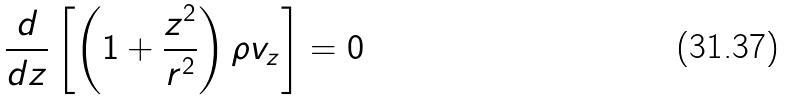<formula> <loc_0><loc_0><loc_500><loc_500>\frac { d } { d z } \left [ \left ( 1 + \frac { z ^ { 2 } } { r ^ { 2 } } \right ) \rho { v } _ { z } \right ] = 0</formula> 